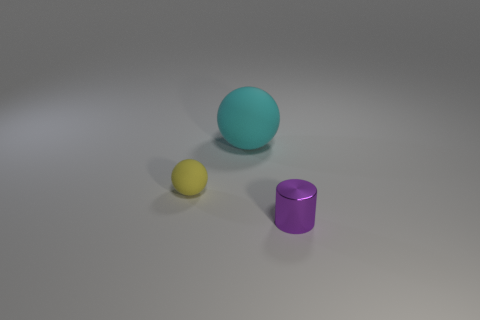What could be the possible use for these objects if they were real physical items? If these objects were real, the two spheres could possibly be decorative elements or part of a learning resource for children, enabling them to understand shapes and sizes. The cylinder might be a container or a simple building block for construction play. Their similar sizes but different shapes could be key in teaching sorting and categorization. 